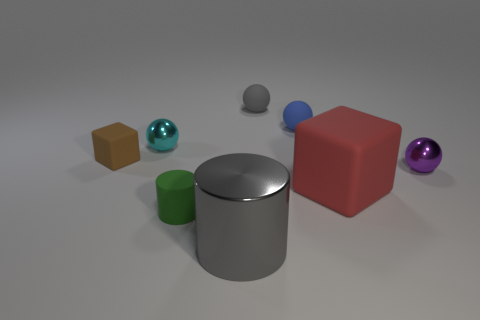Subtract all purple metallic spheres. How many spheres are left? 3 Add 2 big cylinders. How many objects exist? 10 Subtract all cyan spheres. How many spheres are left? 3 Subtract all cubes. How many objects are left? 6 Subtract all purple spheres. Subtract all red blocks. How many spheres are left? 3 Add 6 brown matte things. How many brown matte things exist? 7 Subtract 1 red cubes. How many objects are left? 7 Subtract all red metal objects. Subtract all metallic cylinders. How many objects are left? 7 Add 5 matte objects. How many matte objects are left? 10 